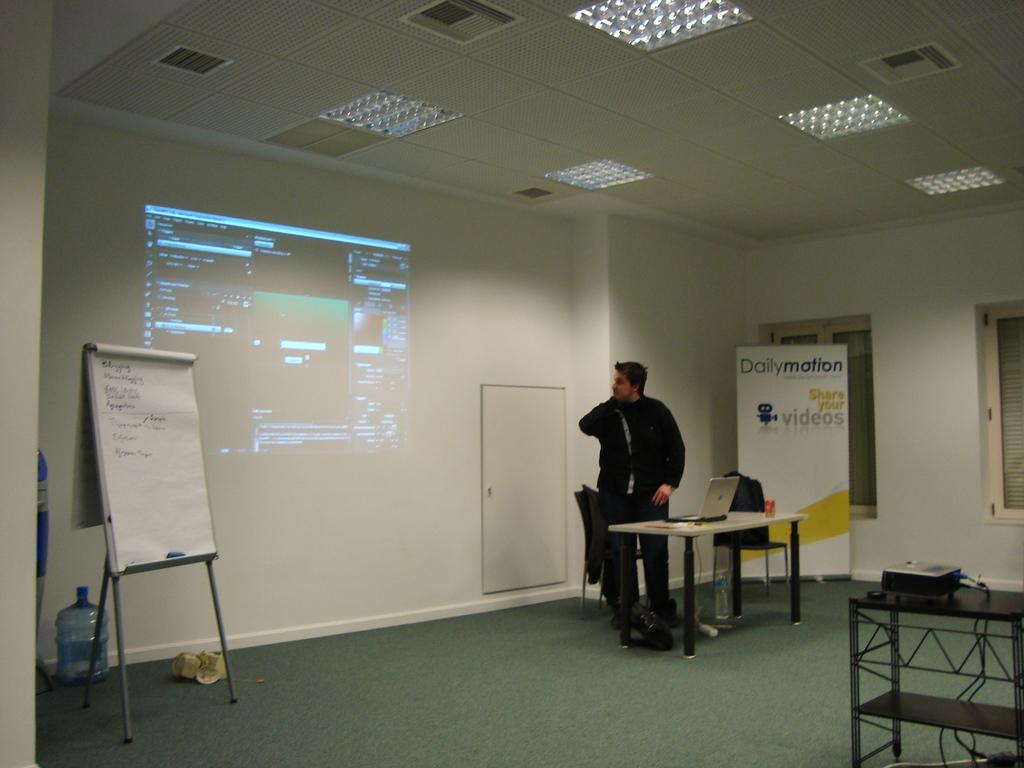<image>
Render a clear and concise summary of the photo. A man stands at the front of a room giving a presentation with images projected on the wall from Daily Motion. 